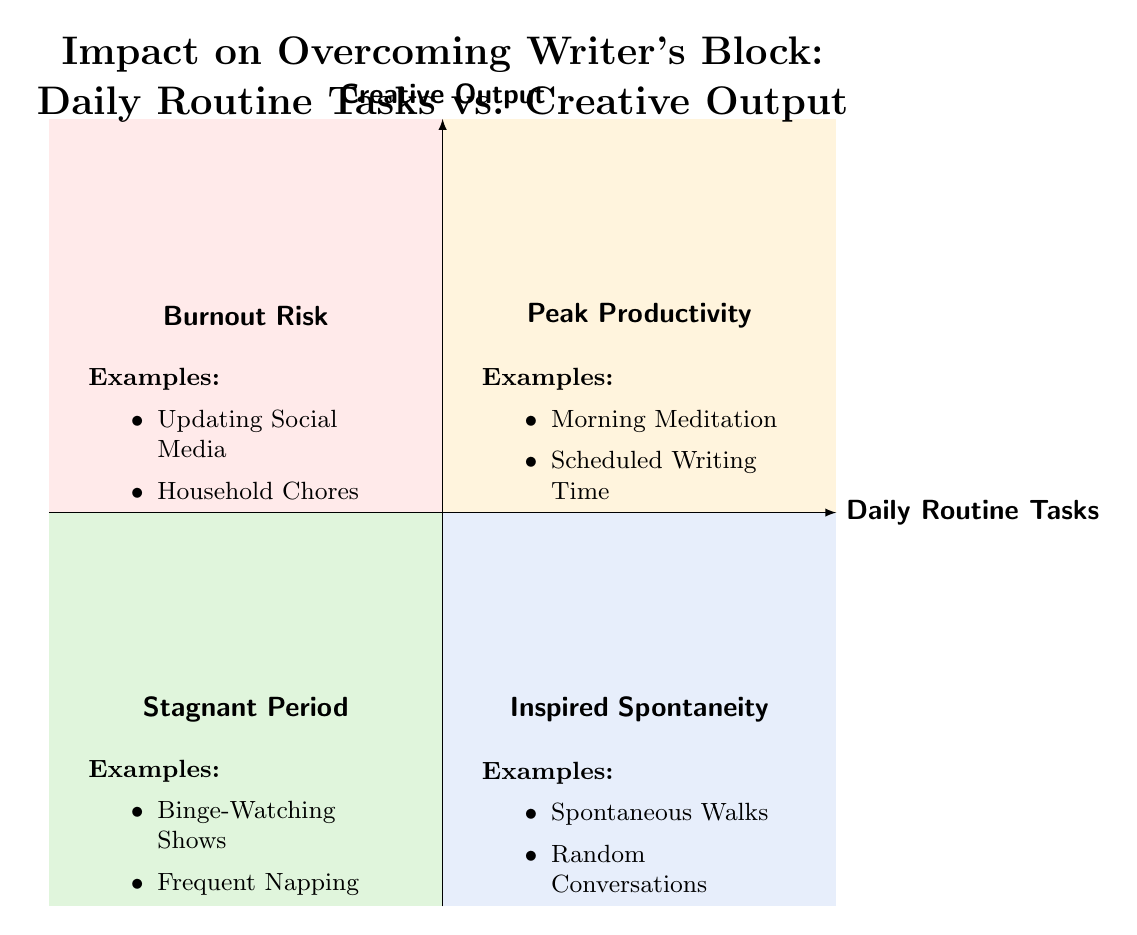What is the label of the quadrant with high daily routine tasks and high creative output? The quadrant located in the upper right section of the diagram represents high daily routine tasks and high creative output. It is specifically labeled as "Peak Productivity."
Answer: Peak Productivity What task is associated with the "Burnout Risk" quadrant? In the "Burnout Risk" quadrant, one of the tasks listed is "Updating Social Media," which is present in the lower left section.
Answer: Updating Social Media How many quadrants are shown in this diagram? The diagram consists of four distinct quadrants, categorized based on the combinations of daily routine tasks and creative output.
Answer: Four What are the two examples given in the "Inspired Spontaneity" quadrant? The "Inspired Spontaneity" quadrant contains two examples of tasks leading to creative output: "Spontaneous Walks" and "Random Conversations."
Answer: Spontaneous Walks, Random Conversations Which quadrant has the lowest creative output? The quadrant that displays the lowest creative output, as indicated by its position in the lower left, is labeled "Stagnant Period."
Answer: Stagnant Period Which tasks lead to "New Story Ideas"? The task "Morning Meditation," found in the "Peak Productivity" quadrant, is a noted contributor to generating "New Story Ideas."
Answer: Morning Meditation What is the creative output result of "Frequent Napping"? "Frequent Napping," listed in the "Stagnant Period" quadrant, is noted to produce no creative output, specifically stated as "Writer's Block Persisting."
Answer: Writer's Block Persisting Which quadrant is characterized by a high number of routine tasks but minimal creative output? The quadrant characterized by a high number of routine tasks and minimal creative output is labeled "Burnout Risk," located in the upper left section of the diagram.
Answer: Burnout Risk 